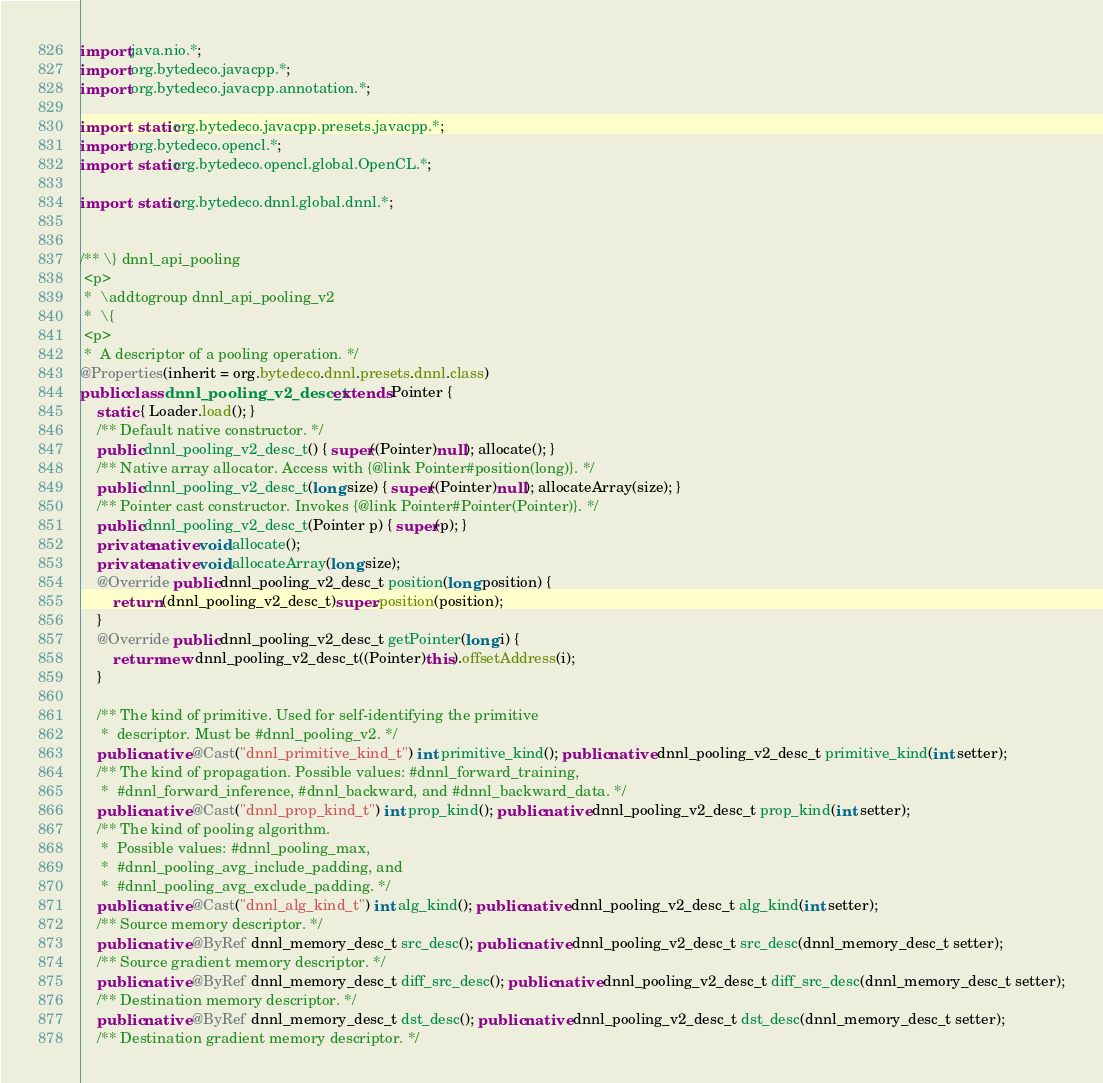Convert code to text. <code><loc_0><loc_0><loc_500><loc_500><_Java_>
import java.nio.*;
import org.bytedeco.javacpp.*;
import org.bytedeco.javacpp.annotation.*;

import static org.bytedeco.javacpp.presets.javacpp.*;
import org.bytedeco.opencl.*;
import static org.bytedeco.opencl.global.OpenCL.*;

import static org.bytedeco.dnnl.global.dnnl.*;


/** \} dnnl_api_pooling
 <p>
 *  \addtogroup dnnl_api_pooling_v2
 *  \{
 <p>
 *  A descriptor of a pooling operation. */
@Properties(inherit = org.bytedeco.dnnl.presets.dnnl.class)
public class dnnl_pooling_v2_desc_t extends Pointer {
    static { Loader.load(); }
    /** Default native constructor. */
    public dnnl_pooling_v2_desc_t() { super((Pointer)null); allocate(); }
    /** Native array allocator. Access with {@link Pointer#position(long)}. */
    public dnnl_pooling_v2_desc_t(long size) { super((Pointer)null); allocateArray(size); }
    /** Pointer cast constructor. Invokes {@link Pointer#Pointer(Pointer)}. */
    public dnnl_pooling_v2_desc_t(Pointer p) { super(p); }
    private native void allocate();
    private native void allocateArray(long size);
    @Override public dnnl_pooling_v2_desc_t position(long position) {
        return (dnnl_pooling_v2_desc_t)super.position(position);
    }
    @Override public dnnl_pooling_v2_desc_t getPointer(long i) {
        return new dnnl_pooling_v2_desc_t((Pointer)this).offsetAddress(i);
    }

    /** The kind of primitive. Used for self-identifying the primitive
     *  descriptor. Must be #dnnl_pooling_v2. */
    public native @Cast("dnnl_primitive_kind_t") int primitive_kind(); public native dnnl_pooling_v2_desc_t primitive_kind(int setter);
    /** The kind of propagation. Possible values: #dnnl_forward_training,
     *  #dnnl_forward_inference, #dnnl_backward, and #dnnl_backward_data. */
    public native @Cast("dnnl_prop_kind_t") int prop_kind(); public native dnnl_pooling_v2_desc_t prop_kind(int setter);
    /** The kind of pooling algorithm.
     *  Possible values: #dnnl_pooling_max,
     *  #dnnl_pooling_avg_include_padding, and
     *  #dnnl_pooling_avg_exclude_padding. */
    public native @Cast("dnnl_alg_kind_t") int alg_kind(); public native dnnl_pooling_v2_desc_t alg_kind(int setter);
    /** Source memory descriptor. */
    public native @ByRef dnnl_memory_desc_t src_desc(); public native dnnl_pooling_v2_desc_t src_desc(dnnl_memory_desc_t setter);
    /** Source gradient memory descriptor. */
    public native @ByRef dnnl_memory_desc_t diff_src_desc(); public native dnnl_pooling_v2_desc_t diff_src_desc(dnnl_memory_desc_t setter);
    /** Destination memory descriptor. */
    public native @ByRef dnnl_memory_desc_t dst_desc(); public native dnnl_pooling_v2_desc_t dst_desc(dnnl_memory_desc_t setter);
    /** Destination gradient memory descriptor. */</code> 